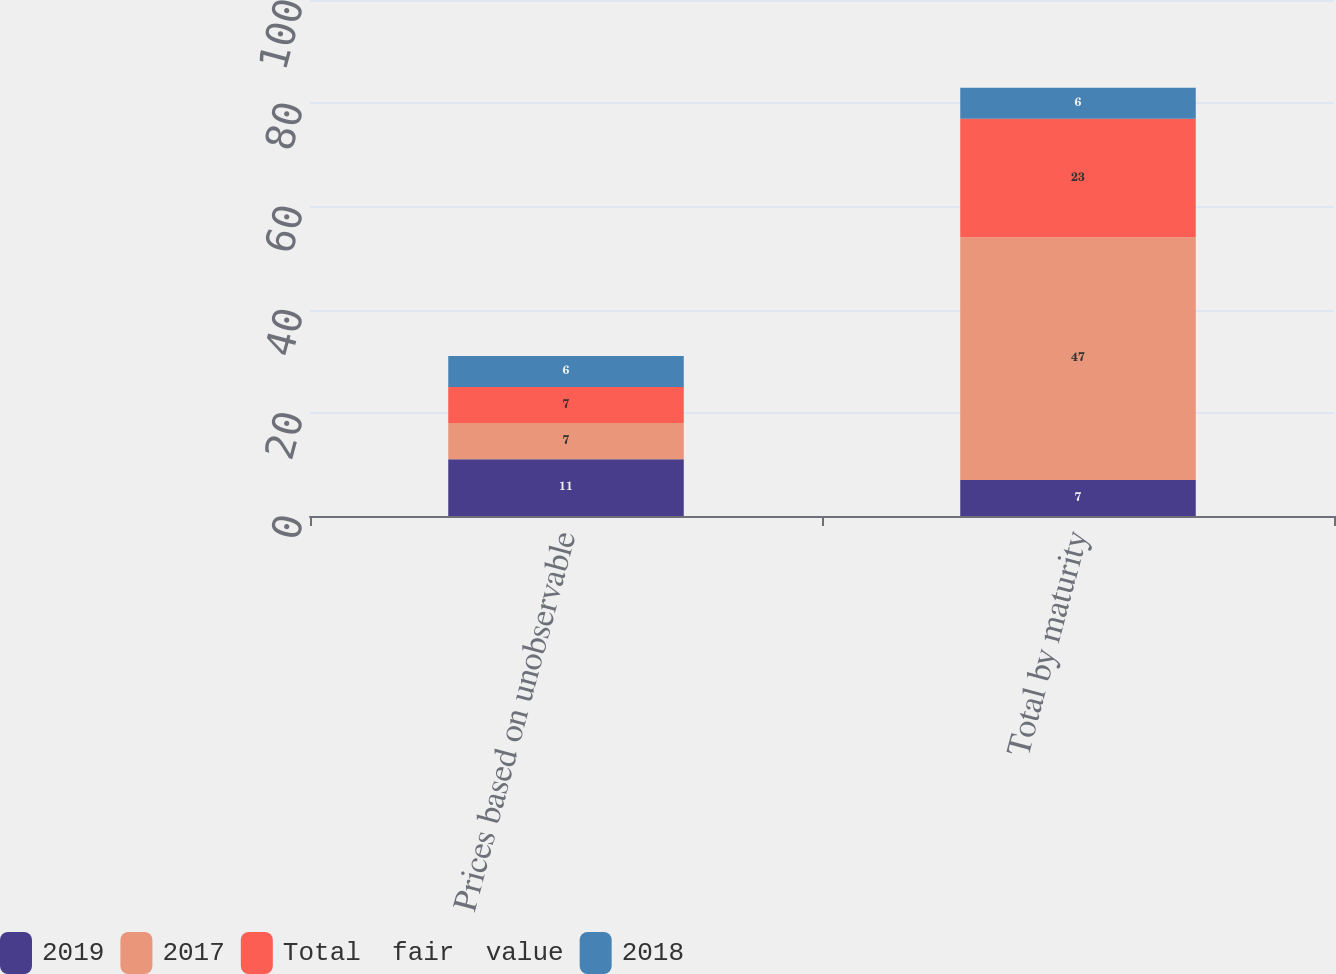Convert chart. <chart><loc_0><loc_0><loc_500><loc_500><stacked_bar_chart><ecel><fcel>Prices based on unobservable<fcel>Total by maturity<nl><fcel>2019<fcel>11<fcel>7<nl><fcel>2017<fcel>7<fcel>47<nl><fcel>Total  fair  value<fcel>7<fcel>23<nl><fcel>2018<fcel>6<fcel>6<nl></chart> 